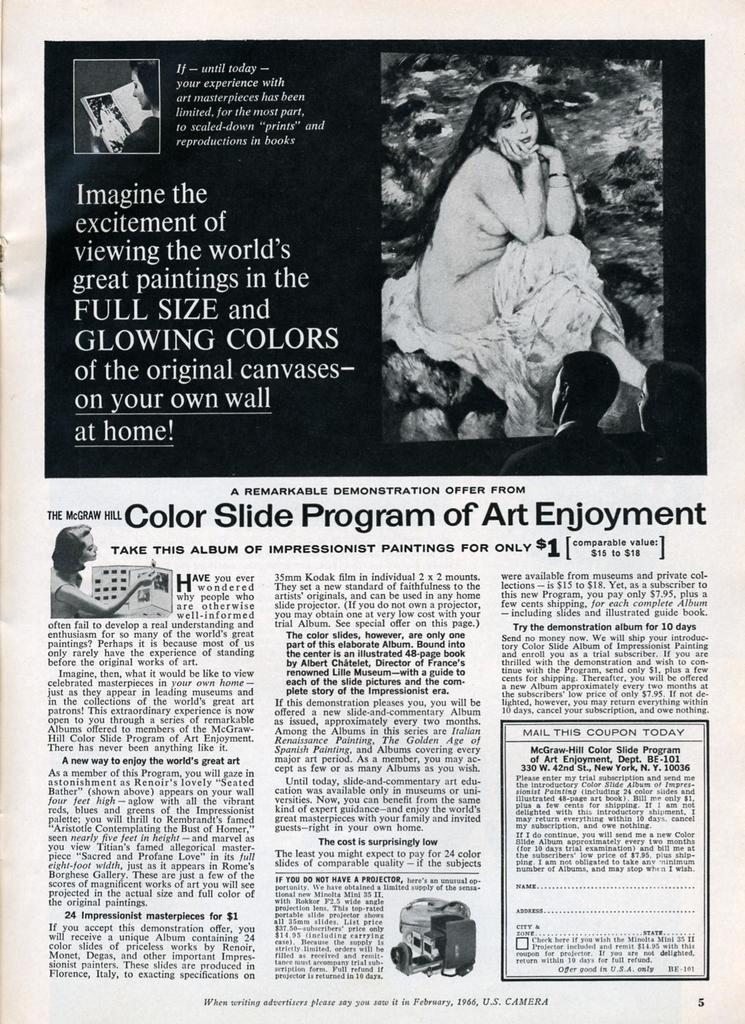What type of paper is visible in the image? There is a magazine paper in the image. What can be seen on the magazine paper? There are photographs in the image. What type of artwork is present in the image? There is a painting in the image. What type of content is present in the image? There is text in the image. What type of humor can be found in the painting in the image? There is no humor present in the painting in the image, as the facts provided do not mention any humorous elements. 